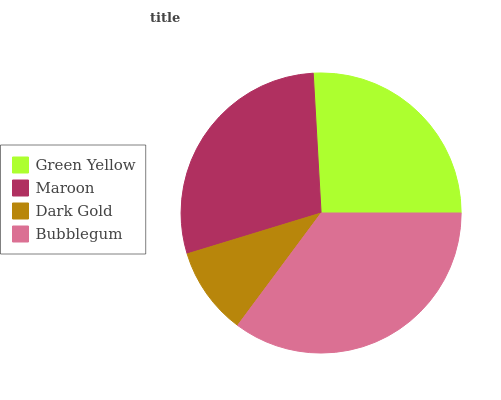Is Dark Gold the minimum?
Answer yes or no. Yes. Is Bubblegum the maximum?
Answer yes or no. Yes. Is Maroon the minimum?
Answer yes or no. No. Is Maroon the maximum?
Answer yes or no. No. Is Maroon greater than Green Yellow?
Answer yes or no. Yes. Is Green Yellow less than Maroon?
Answer yes or no. Yes. Is Green Yellow greater than Maroon?
Answer yes or no. No. Is Maroon less than Green Yellow?
Answer yes or no. No. Is Maroon the high median?
Answer yes or no. Yes. Is Green Yellow the low median?
Answer yes or no. Yes. Is Green Yellow the high median?
Answer yes or no. No. Is Maroon the low median?
Answer yes or no. No. 